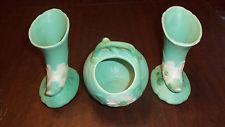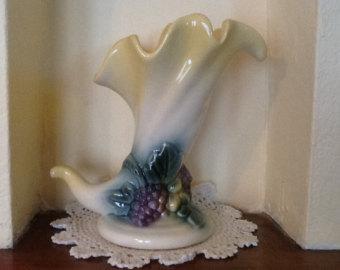The first image is the image on the left, the second image is the image on the right. Assess this claim about the two images: "Each image contains at least two vases shaped like ocean waves, and the left image shows the waves facing each other, while the right image shows them aimed leftward.". Correct or not? Answer yes or no. No. The first image is the image on the left, the second image is the image on the right. Considering the images on both sides, is "Each image contains a pair of matching objects." valid? Answer yes or no. No. 